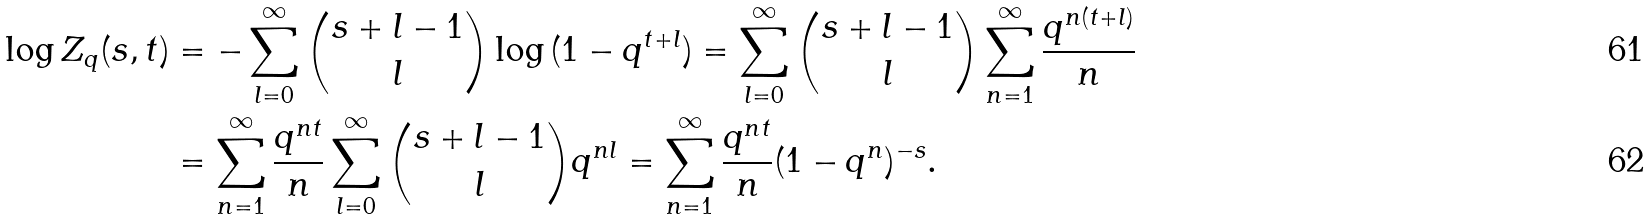Convert formula to latex. <formula><loc_0><loc_0><loc_500><loc_500>\log { Z _ { q } ( s , t ) } & = - \sum ^ { \infty } _ { l = 0 } \binom { s + l - 1 } { l } \log { ( 1 - q ^ { t + l } ) } = \sum ^ { \infty } _ { l = 0 } \binom { s + l - 1 } { l } \sum ^ { \infty } _ { n = 1 } \frac { q ^ { n ( t + l ) } } { n } \\ & = \sum ^ { \infty } _ { n = 1 } \frac { q ^ { n t } } { n } \sum ^ { \infty } _ { l = 0 } \binom { s + l - 1 } { l } q ^ { n l } = \sum ^ { \infty } _ { n = 1 } \frac { q ^ { n t } } { n } ( 1 - q ^ { n } ) ^ { - s } .</formula> 